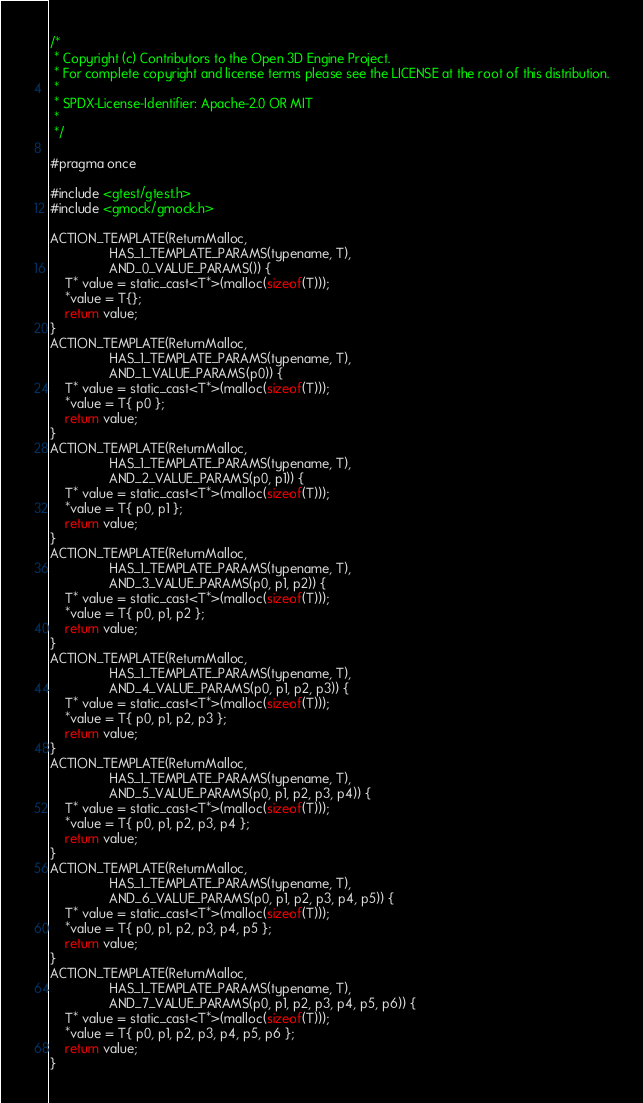Convert code to text. <code><loc_0><loc_0><loc_500><loc_500><_C_>/*
 * Copyright (c) Contributors to the Open 3D Engine Project.
 * For complete copyright and license terms please see the LICENSE at the root of this distribution.
 *
 * SPDX-License-Identifier: Apache-2.0 OR MIT
 *
 */

#pragma once

#include <gtest/gtest.h>
#include <gmock/gmock.h>

ACTION_TEMPLATE(ReturnMalloc,
                HAS_1_TEMPLATE_PARAMS(typename, T),
                AND_0_VALUE_PARAMS()) {
    T* value = static_cast<T*>(malloc(sizeof(T)));
    *value = T{};
    return value;
}
ACTION_TEMPLATE(ReturnMalloc,
                HAS_1_TEMPLATE_PARAMS(typename, T),
                AND_1_VALUE_PARAMS(p0)) {
    T* value = static_cast<T*>(malloc(sizeof(T)));
    *value = T{ p0 };
    return value;
}
ACTION_TEMPLATE(ReturnMalloc,
                HAS_1_TEMPLATE_PARAMS(typename, T),
                AND_2_VALUE_PARAMS(p0, p1)) {
    T* value = static_cast<T*>(malloc(sizeof(T)));
    *value = T{ p0, p1 };
    return value;
}
ACTION_TEMPLATE(ReturnMalloc,
                HAS_1_TEMPLATE_PARAMS(typename, T),
                AND_3_VALUE_PARAMS(p0, p1, p2)) {
    T* value = static_cast<T*>(malloc(sizeof(T)));
    *value = T{ p0, p1, p2 };
    return value;
}
ACTION_TEMPLATE(ReturnMalloc,
                HAS_1_TEMPLATE_PARAMS(typename, T),
                AND_4_VALUE_PARAMS(p0, p1, p2, p3)) {
    T* value = static_cast<T*>(malloc(sizeof(T)));
    *value = T{ p0, p1, p2, p3 };
    return value;
}
ACTION_TEMPLATE(ReturnMalloc,
                HAS_1_TEMPLATE_PARAMS(typename, T),
                AND_5_VALUE_PARAMS(p0, p1, p2, p3, p4)) {
    T* value = static_cast<T*>(malloc(sizeof(T)));
    *value = T{ p0, p1, p2, p3, p4 };
    return value;
}
ACTION_TEMPLATE(ReturnMalloc,
                HAS_1_TEMPLATE_PARAMS(typename, T),
                AND_6_VALUE_PARAMS(p0, p1, p2, p3, p4, p5)) {
    T* value = static_cast<T*>(malloc(sizeof(T)));
    *value = T{ p0, p1, p2, p3, p4, p5 };
    return value;
}
ACTION_TEMPLATE(ReturnMalloc,
                HAS_1_TEMPLATE_PARAMS(typename, T),
                AND_7_VALUE_PARAMS(p0, p1, p2, p3, p4, p5, p6)) {
    T* value = static_cast<T*>(malloc(sizeof(T)));
    *value = T{ p0, p1, p2, p3, p4, p5, p6 };
    return value;
}
</code> 